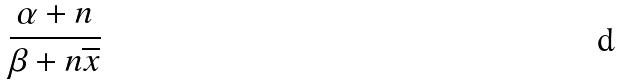Convert formula to latex. <formula><loc_0><loc_0><loc_500><loc_500>\frac { \alpha + n } { \beta + n \overline { x } }</formula> 